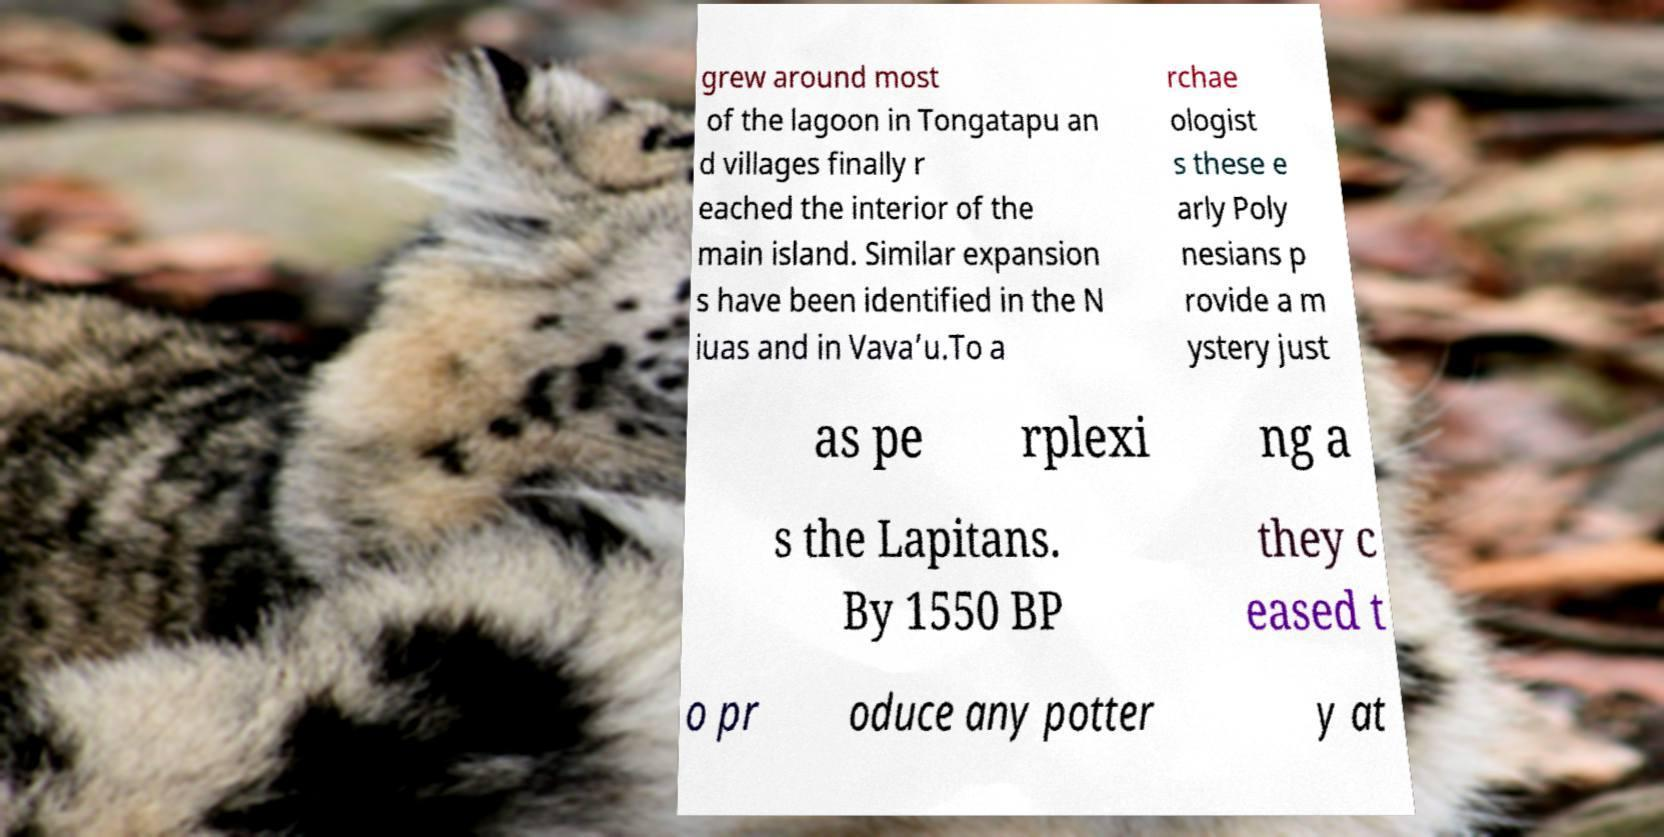Please read and relay the text visible in this image. What does it say? grew around most of the lagoon in Tongatapu an d villages finally r eached the interior of the main island. Similar expansion s have been identified in the N iuas and in Vava’u.To a rchae ologist s these e arly Poly nesians p rovide a m ystery just as pe rplexi ng a s the Lapitans. By 1550 BP they c eased t o pr oduce any potter y at 